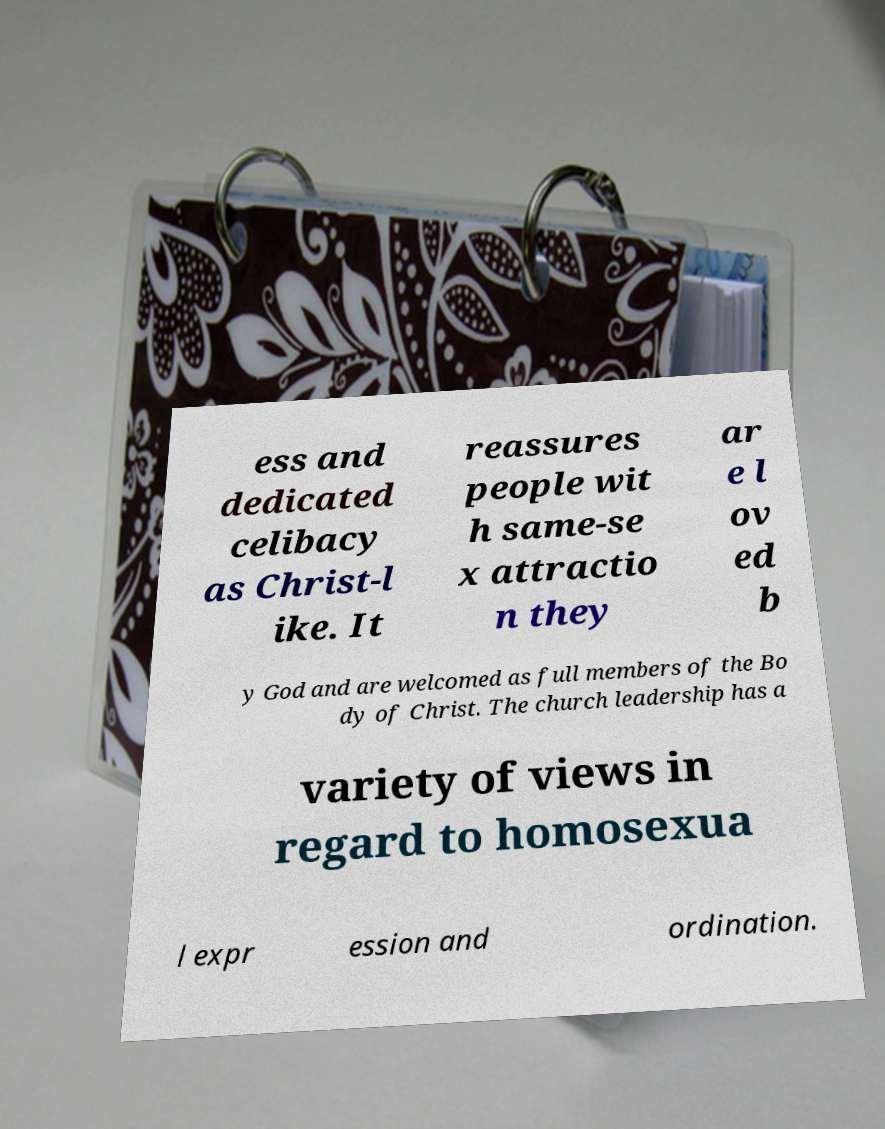Please identify and transcribe the text found in this image. ess and dedicated celibacy as Christ-l ike. It reassures people wit h same-se x attractio n they ar e l ov ed b y God and are welcomed as full members of the Bo dy of Christ. The church leadership has a variety of views in regard to homosexua l expr ession and ordination. 